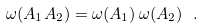Convert formula to latex. <formula><loc_0><loc_0><loc_500><loc_500>\omega ( A _ { 1 } A _ { 2 } ) = \omega ( A _ { 1 } ) \, \omega ( A _ { 2 } ) \ .</formula> 